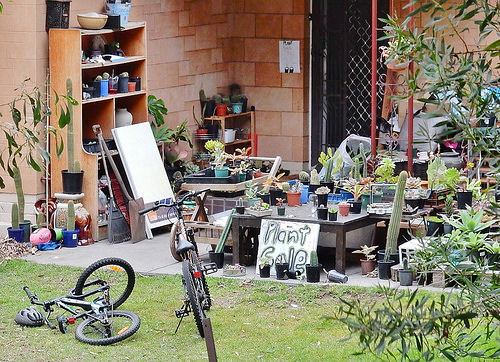<image>
Can you confirm if the sign is in front of the bike? No. The sign is not in front of the bike. The spatial positioning shows a different relationship between these objects. 